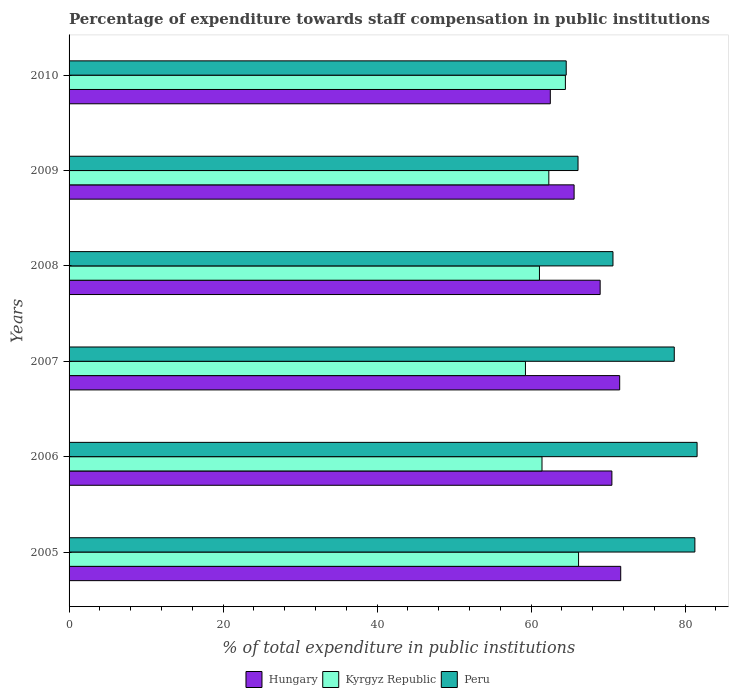How many different coloured bars are there?
Keep it short and to the point. 3. How many groups of bars are there?
Keep it short and to the point. 6. Are the number of bars on each tick of the Y-axis equal?
Make the answer very short. Yes. What is the label of the 3rd group of bars from the top?
Your response must be concise. 2008. In how many cases, is the number of bars for a given year not equal to the number of legend labels?
Provide a short and direct response. 0. What is the percentage of expenditure towards staff compensation in Peru in 2010?
Your answer should be very brief. 64.57. Across all years, what is the maximum percentage of expenditure towards staff compensation in Hungary?
Your answer should be compact. 71.64. Across all years, what is the minimum percentage of expenditure towards staff compensation in Hungary?
Offer a terse response. 62.5. In which year was the percentage of expenditure towards staff compensation in Peru maximum?
Offer a terse response. 2006. What is the total percentage of expenditure towards staff compensation in Hungary in the graph?
Make the answer very short. 410.7. What is the difference between the percentage of expenditure towards staff compensation in Kyrgyz Republic in 2006 and that in 2009?
Give a very brief answer. -0.89. What is the difference between the percentage of expenditure towards staff compensation in Kyrgyz Republic in 2005 and the percentage of expenditure towards staff compensation in Peru in 2008?
Your answer should be compact. -4.47. What is the average percentage of expenditure towards staff compensation in Kyrgyz Republic per year?
Offer a very short reply. 62.45. In the year 2010, what is the difference between the percentage of expenditure towards staff compensation in Kyrgyz Republic and percentage of expenditure towards staff compensation in Hungary?
Offer a very short reply. 1.96. What is the ratio of the percentage of expenditure towards staff compensation in Hungary in 2008 to that in 2010?
Ensure brevity in your answer.  1.1. Is the percentage of expenditure towards staff compensation in Kyrgyz Republic in 2008 less than that in 2009?
Provide a succinct answer. Yes. Is the difference between the percentage of expenditure towards staff compensation in Kyrgyz Republic in 2007 and 2010 greater than the difference between the percentage of expenditure towards staff compensation in Hungary in 2007 and 2010?
Your response must be concise. No. What is the difference between the highest and the second highest percentage of expenditure towards staff compensation in Hungary?
Offer a terse response. 0.13. What is the difference between the highest and the lowest percentage of expenditure towards staff compensation in Hungary?
Offer a terse response. 9.14. In how many years, is the percentage of expenditure towards staff compensation in Hungary greater than the average percentage of expenditure towards staff compensation in Hungary taken over all years?
Your response must be concise. 4. Is the sum of the percentage of expenditure towards staff compensation in Kyrgyz Republic in 2005 and 2009 greater than the maximum percentage of expenditure towards staff compensation in Hungary across all years?
Make the answer very short. Yes. What does the 3rd bar from the top in 2007 represents?
Your response must be concise. Hungary. What does the 3rd bar from the bottom in 2009 represents?
Provide a succinct answer. Peru. Is it the case that in every year, the sum of the percentage of expenditure towards staff compensation in Hungary and percentage of expenditure towards staff compensation in Peru is greater than the percentage of expenditure towards staff compensation in Kyrgyz Republic?
Provide a short and direct response. Yes. How many bars are there?
Your answer should be very brief. 18. How many years are there in the graph?
Give a very brief answer. 6. What is the difference between two consecutive major ticks on the X-axis?
Make the answer very short. 20. Are the values on the major ticks of X-axis written in scientific E-notation?
Make the answer very short. No. Does the graph contain any zero values?
Offer a very short reply. No. Where does the legend appear in the graph?
Your response must be concise. Bottom center. How many legend labels are there?
Offer a very short reply. 3. What is the title of the graph?
Provide a short and direct response. Percentage of expenditure towards staff compensation in public institutions. Does "Small states" appear as one of the legend labels in the graph?
Provide a succinct answer. No. What is the label or title of the X-axis?
Give a very brief answer. % of total expenditure in public institutions. What is the label or title of the Y-axis?
Keep it short and to the point. Years. What is the % of total expenditure in public institutions in Hungary in 2005?
Keep it short and to the point. 71.64. What is the % of total expenditure in public institutions in Kyrgyz Republic in 2005?
Make the answer very short. 66.17. What is the % of total expenditure in public institutions of Peru in 2005?
Give a very brief answer. 81.27. What is the % of total expenditure in public institutions of Hungary in 2006?
Offer a terse response. 70.49. What is the % of total expenditure in public institutions in Kyrgyz Republic in 2006?
Offer a terse response. 61.42. What is the % of total expenditure in public institutions of Peru in 2006?
Your response must be concise. 81.56. What is the % of total expenditure in public institutions of Hungary in 2007?
Your answer should be very brief. 71.51. What is the % of total expenditure in public institutions in Kyrgyz Republic in 2007?
Your response must be concise. 59.27. What is the % of total expenditure in public institutions in Peru in 2007?
Your answer should be very brief. 78.6. What is the % of total expenditure in public institutions of Hungary in 2008?
Your answer should be very brief. 68.97. What is the % of total expenditure in public institutions of Kyrgyz Republic in 2008?
Your response must be concise. 61.09. What is the % of total expenditure in public institutions of Peru in 2008?
Provide a succinct answer. 70.64. What is the % of total expenditure in public institutions in Hungary in 2009?
Provide a succinct answer. 65.59. What is the % of total expenditure in public institutions in Kyrgyz Republic in 2009?
Your response must be concise. 62.3. What is the % of total expenditure in public institutions of Peru in 2009?
Provide a succinct answer. 66.1. What is the % of total expenditure in public institutions of Hungary in 2010?
Give a very brief answer. 62.5. What is the % of total expenditure in public institutions in Kyrgyz Republic in 2010?
Provide a succinct answer. 64.46. What is the % of total expenditure in public institutions of Peru in 2010?
Provide a succinct answer. 64.57. Across all years, what is the maximum % of total expenditure in public institutions in Hungary?
Give a very brief answer. 71.64. Across all years, what is the maximum % of total expenditure in public institutions in Kyrgyz Republic?
Make the answer very short. 66.17. Across all years, what is the maximum % of total expenditure in public institutions of Peru?
Offer a terse response. 81.56. Across all years, what is the minimum % of total expenditure in public institutions in Hungary?
Keep it short and to the point. 62.5. Across all years, what is the minimum % of total expenditure in public institutions of Kyrgyz Republic?
Ensure brevity in your answer.  59.27. Across all years, what is the minimum % of total expenditure in public institutions in Peru?
Make the answer very short. 64.57. What is the total % of total expenditure in public institutions in Hungary in the graph?
Offer a terse response. 410.7. What is the total % of total expenditure in public institutions of Kyrgyz Republic in the graph?
Keep it short and to the point. 374.7. What is the total % of total expenditure in public institutions in Peru in the graph?
Your response must be concise. 442.73. What is the difference between the % of total expenditure in public institutions of Hungary in 2005 and that in 2006?
Your response must be concise. 1.15. What is the difference between the % of total expenditure in public institutions of Kyrgyz Republic in 2005 and that in 2006?
Make the answer very short. 4.75. What is the difference between the % of total expenditure in public institutions of Peru in 2005 and that in 2006?
Make the answer very short. -0.29. What is the difference between the % of total expenditure in public institutions in Hungary in 2005 and that in 2007?
Give a very brief answer. 0.13. What is the difference between the % of total expenditure in public institutions of Kyrgyz Republic in 2005 and that in 2007?
Ensure brevity in your answer.  6.9. What is the difference between the % of total expenditure in public institutions in Peru in 2005 and that in 2007?
Offer a very short reply. 2.68. What is the difference between the % of total expenditure in public institutions of Hungary in 2005 and that in 2008?
Offer a terse response. 2.67. What is the difference between the % of total expenditure in public institutions of Kyrgyz Republic in 2005 and that in 2008?
Your answer should be compact. 5.08. What is the difference between the % of total expenditure in public institutions in Peru in 2005 and that in 2008?
Offer a very short reply. 10.64. What is the difference between the % of total expenditure in public institutions of Hungary in 2005 and that in 2009?
Offer a terse response. 6.05. What is the difference between the % of total expenditure in public institutions of Kyrgyz Republic in 2005 and that in 2009?
Give a very brief answer. 3.86. What is the difference between the % of total expenditure in public institutions of Peru in 2005 and that in 2009?
Provide a short and direct response. 15.17. What is the difference between the % of total expenditure in public institutions in Hungary in 2005 and that in 2010?
Your answer should be compact. 9.14. What is the difference between the % of total expenditure in public institutions in Kyrgyz Republic in 2005 and that in 2010?
Keep it short and to the point. 1.71. What is the difference between the % of total expenditure in public institutions of Peru in 2005 and that in 2010?
Offer a terse response. 16.71. What is the difference between the % of total expenditure in public institutions in Hungary in 2006 and that in 2007?
Your answer should be very brief. -1.01. What is the difference between the % of total expenditure in public institutions of Kyrgyz Republic in 2006 and that in 2007?
Ensure brevity in your answer.  2.15. What is the difference between the % of total expenditure in public institutions in Peru in 2006 and that in 2007?
Make the answer very short. 2.97. What is the difference between the % of total expenditure in public institutions of Hungary in 2006 and that in 2008?
Your answer should be very brief. 1.52. What is the difference between the % of total expenditure in public institutions of Kyrgyz Republic in 2006 and that in 2008?
Your answer should be compact. 0.33. What is the difference between the % of total expenditure in public institutions of Peru in 2006 and that in 2008?
Your answer should be compact. 10.92. What is the difference between the % of total expenditure in public institutions in Hungary in 2006 and that in 2009?
Your answer should be compact. 4.91. What is the difference between the % of total expenditure in public institutions in Kyrgyz Republic in 2006 and that in 2009?
Make the answer very short. -0.89. What is the difference between the % of total expenditure in public institutions in Peru in 2006 and that in 2009?
Your response must be concise. 15.46. What is the difference between the % of total expenditure in public institutions in Hungary in 2006 and that in 2010?
Your answer should be very brief. 8. What is the difference between the % of total expenditure in public institutions of Kyrgyz Republic in 2006 and that in 2010?
Offer a terse response. -3.04. What is the difference between the % of total expenditure in public institutions of Peru in 2006 and that in 2010?
Provide a succinct answer. 17. What is the difference between the % of total expenditure in public institutions of Hungary in 2007 and that in 2008?
Provide a short and direct response. 2.54. What is the difference between the % of total expenditure in public institutions in Kyrgyz Republic in 2007 and that in 2008?
Ensure brevity in your answer.  -1.82. What is the difference between the % of total expenditure in public institutions of Peru in 2007 and that in 2008?
Ensure brevity in your answer.  7.96. What is the difference between the % of total expenditure in public institutions in Hungary in 2007 and that in 2009?
Your answer should be compact. 5.92. What is the difference between the % of total expenditure in public institutions in Kyrgyz Republic in 2007 and that in 2009?
Offer a terse response. -3.04. What is the difference between the % of total expenditure in public institutions of Peru in 2007 and that in 2009?
Give a very brief answer. 12.5. What is the difference between the % of total expenditure in public institutions in Hungary in 2007 and that in 2010?
Make the answer very short. 9.01. What is the difference between the % of total expenditure in public institutions in Kyrgyz Republic in 2007 and that in 2010?
Your answer should be compact. -5.19. What is the difference between the % of total expenditure in public institutions in Peru in 2007 and that in 2010?
Your answer should be very brief. 14.03. What is the difference between the % of total expenditure in public institutions in Hungary in 2008 and that in 2009?
Offer a very short reply. 3.38. What is the difference between the % of total expenditure in public institutions in Kyrgyz Republic in 2008 and that in 2009?
Provide a short and direct response. -1.22. What is the difference between the % of total expenditure in public institutions of Peru in 2008 and that in 2009?
Provide a short and direct response. 4.54. What is the difference between the % of total expenditure in public institutions of Hungary in 2008 and that in 2010?
Offer a very short reply. 6.47. What is the difference between the % of total expenditure in public institutions of Kyrgyz Republic in 2008 and that in 2010?
Your answer should be very brief. -3.37. What is the difference between the % of total expenditure in public institutions of Peru in 2008 and that in 2010?
Your answer should be compact. 6.07. What is the difference between the % of total expenditure in public institutions of Hungary in 2009 and that in 2010?
Provide a short and direct response. 3.09. What is the difference between the % of total expenditure in public institutions of Kyrgyz Republic in 2009 and that in 2010?
Keep it short and to the point. -2.15. What is the difference between the % of total expenditure in public institutions of Peru in 2009 and that in 2010?
Your response must be concise. 1.53. What is the difference between the % of total expenditure in public institutions of Hungary in 2005 and the % of total expenditure in public institutions of Kyrgyz Republic in 2006?
Provide a short and direct response. 10.22. What is the difference between the % of total expenditure in public institutions of Hungary in 2005 and the % of total expenditure in public institutions of Peru in 2006?
Give a very brief answer. -9.92. What is the difference between the % of total expenditure in public institutions of Kyrgyz Republic in 2005 and the % of total expenditure in public institutions of Peru in 2006?
Your response must be concise. -15.39. What is the difference between the % of total expenditure in public institutions of Hungary in 2005 and the % of total expenditure in public institutions of Kyrgyz Republic in 2007?
Ensure brevity in your answer.  12.37. What is the difference between the % of total expenditure in public institutions of Hungary in 2005 and the % of total expenditure in public institutions of Peru in 2007?
Your response must be concise. -6.95. What is the difference between the % of total expenditure in public institutions of Kyrgyz Republic in 2005 and the % of total expenditure in public institutions of Peru in 2007?
Keep it short and to the point. -12.43. What is the difference between the % of total expenditure in public institutions of Hungary in 2005 and the % of total expenditure in public institutions of Kyrgyz Republic in 2008?
Ensure brevity in your answer.  10.56. What is the difference between the % of total expenditure in public institutions of Hungary in 2005 and the % of total expenditure in public institutions of Peru in 2008?
Give a very brief answer. 1.01. What is the difference between the % of total expenditure in public institutions of Kyrgyz Republic in 2005 and the % of total expenditure in public institutions of Peru in 2008?
Offer a very short reply. -4.47. What is the difference between the % of total expenditure in public institutions in Hungary in 2005 and the % of total expenditure in public institutions in Kyrgyz Republic in 2009?
Your answer should be compact. 9.34. What is the difference between the % of total expenditure in public institutions in Hungary in 2005 and the % of total expenditure in public institutions in Peru in 2009?
Offer a very short reply. 5.54. What is the difference between the % of total expenditure in public institutions of Kyrgyz Republic in 2005 and the % of total expenditure in public institutions of Peru in 2009?
Your answer should be compact. 0.07. What is the difference between the % of total expenditure in public institutions of Hungary in 2005 and the % of total expenditure in public institutions of Kyrgyz Republic in 2010?
Your answer should be compact. 7.19. What is the difference between the % of total expenditure in public institutions in Hungary in 2005 and the % of total expenditure in public institutions in Peru in 2010?
Your response must be concise. 7.08. What is the difference between the % of total expenditure in public institutions in Kyrgyz Republic in 2005 and the % of total expenditure in public institutions in Peru in 2010?
Ensure brevity in your answer.  1.6. What is the difference between the % of total expenditure in public institutions of Hungary in 2006 and the % of total expenditure in public institutions of Kyrgyz Republic in 2007?
Your response must be concise. 11.22. What is the difference between the % of total expenditure in public institutions of Hungary in 2006 and the % of total expenditure in public institutions of Peru in 2007?
Provide a succinct answer. -8.1. What is the difference between the % of total expenditure in public institutions in Kyrgyz Republic in 2006 and the % of total expenditure in public institutions in Peru in 2007?
Ensure brevity in your answer.  -17.18. What is the difference between the % of total expenditure in public institutions of Hungary in 2006 and the % of total expenditure in public institutions of Kyrgyz Republic in 2008?
Offer a very short reply. 9.41. What is the difference between the % of total expenditure in public institutions of Hungary in 2006 and the % of total expenditure in public institutions of Peru in 2008?
Keep it short and to the point. -0.14. What is the difference between the % of total expenditure in public institutions in Kyrgyz Republic in 2006 and the % of total expenditure in public institutions in Peru in 2008?
Give a very brief answer. -9.22. What is the difference between the % of total expenditure in public institutions of Hungary in 2006 and the % of total expenditure in public institutions of Kyrgyz Republic in 2009?
Your answer should be compact. 8.19. What is the difference between the % of total expenditure in public institutions of Hungary in 2006 and the % of total expenditure in public institutions of Peru in 2009?
Your answer should be compact. 4.4. What is the difference between the % of total expenditure in public institutions of Kyrgyz Republic in 2006 and the % of total expenditure in public institutions of Peru in 2009?
Offer a very short reply. -4.68. What is the difference between the % of total expenditure in public institutions of Hungary in 2006 and the % of total expenditure in public institutions of Kyrgyz Republic in 2010?
Your response must be concise. 6.04. What is the difference between the % of total expenditure in public institutions in Hungary in 2006 and the % of total expenditure in public institutions in Peru in 2010?
Your answer should be very brief. 5.93. What is the difference between the % of total expenditure in public institutions of Kyrgyz Republic in 2006 and the % of total expenditure in public institutions of Peru in 2010?
Give a very brief answer. -3.15. What is the difference between the % of total expenditure in public institutions in Hungary in 2007 and the % of total expenditure in public institutions in Kyrgyz Republic in 2008?
Your response must be concise. 10.42. What is the difference between the % of total expenditure in public institutions in Hungary in 2007 and the % of total expenditure in public institutions in Peru in 2008?
Your response must be concise. 0.87. What is the difference between the % of total expenditure in public institutions of Kyrgyz Republic in 2007 and the % of total expenditure in public institutions of Peru in 2008?
Make the answer very short. -11.37. What is the difference between the % of total expenditure in public institutions in Hungary in 2007 and the % of total expenditure in public institutions in Kyrgyz Republic in 2009?
Provide a short and direct response. 9.2. What is the difference between the % of total expenditure in public institutions of Hungary in 2007 and the % of total expenditure in public institutions of Peru in 2009?
Your response must be concise. 5.41. What is the difference between the % of total expenditure in public institutions in Kyrgyz Republic in 2007 and the % of total expenditure in public institutions in Peru in 2009?
Ensure brevity in your answer.  -6.83. What is the difference between the % of total expenditure in public institutions of Hungary in 2007 and the % of total expenditure in public institutions of Kyrgyz Republic in 2010?
Offer a very short reply. 7.05. What is the difference between the % of total expenditure in public institutions of Hungary in 2007 and the % of total expenditure in public institutions of Peru in 2010?
Your answer should be compact. 6.94. What is the difference between the % of total expenditure in public institutions of Kyrgyz Republic in 2007 and the % of total expenditure in public institutions of Peru in 2010?
Make the answer very short. -5.3. What is the difference between the % of total expenditure in public institutions in Hungary in 2008 and the % of total expenditure in public institutions in Kyrgyz Republic in 2009?
Provide a short and direct response. 6.67. What is the difference between the % of total expenditure in public institutions of Hungary in 2008 and the % of total expenditure in public institutions of Peru in 2009?
Offer a terse response. 2.87. What is the difference between the % of total expenditure in public institutions of Kyrgyz Republic in 2008 and the % of total expenditure in public institutions of Peru in 2009?
Your answer should be very brief. -5.01. What is the difference between the % of total expenditure in public institutions of Hungary in 2008 and the % of total expenditure in public institutions of Kyrgyz Republic in 2010?
Your answer should be compact. 4.51. What is the difference between the % of total expenditure in public institutions in Hungary in 2008 and the % of total expenditure in public institutions in Peru in 2010?
Provide a succinct answer. 4.41. What is the difference between the % of total expenditure in public institutions in Kyrgyz Republic in 2008 and the % of total expenditure in public institutions in Peru in 2010?
Your answer should be very brief. -3.48. What is the difference between the % of total expenditure in public institutions in Hungary in 2009 and the % of total expenditure in public institutions in Kyrgyz Republic in 2010?
Keep it short and to the point. 1.13. What is the difference between the % of total expenditure in public institutions in Hungary in 2009 and the % of total expenditure in public institutions in Peru in 2010?
Ensure brevity in your answer.  1.02. What is the difference between the % of total expenditure in public institutions of Kyrgyz Republic in 2009 and the % of total expenditure in public institutions of Peru in 2010?
Your response must be concise. -2.26. What is the average % of total expenditure in public institutions in Hungary per year?
Your response must be concise. 68.45. What is the average % of total expenditure in public institutions of Kyrgyz Republic per year?
Your answer should be compact. 62.45. What is the average % of total expenditure in public institutions in Peru per year?
Give a very brief answer. 73.79. In the year 2005, what is the difference between the % of total expenditure in public institutions of Hungary and % of total expenditure in public institutions of Kyrgyz Republic?
Your answer should be compact. 5.47. In the year 2005, what is the difference between the % of total expenditure in public institutions of Hungary and % of total expenditure in public institutions of Peru?
Provide a succinct answer. -9.63. In the year 2005, what is the difference between the % of total expenditure in public institutions in Kyrgyz Republic and % of total expenditure in public institutions in Peru?
Your response must be concise. -15.1. In the year 2006, what is the difference between the % of total expenditure in public institutions of Hungary and % of total expenditure in public institutions of Kyrgyz Republic?
Give a very brief answer. 9.08. In the year 2006, what is the difference between the % of total expenditure in public institutions of Hungary and % of total expenditure in public institutions of Peru?
Your answer should be compact. -11.07. In the year 2006, what is the difference between the % of total expenditure in public institutions in Kyrgyz Republic and % of total expenditure in public institutions in Peru?
Provide a succinct answer. -20.14. In the year 2007, what is the difference between the % of total expenditure in public institutions of Hungary and % of total expenditure in public institutions of Kyrgyz Republic?
Provide a succinct answer. 12.24. In the year 2007, what is the difference between the % of total expenditure in public institutions in Hungary and % of total expenditure in public institutions in Peru?
Give a very brief answer. -7.09. In the year 2007, what is the difference between the % of total expenditure in public institutions in Kyrgyz Republic and % of total expenditure in public institutions in Peru?
Keep it short and to the point. -19.33. In the year 2008, what is the difference between the % of total expenditure in public institutions in Hungary and % of total expenditure in public institutions in Kyrgyz Republic?
Provide a succinct answer. 7.88. In the year 2008, what is the difference between the % of total expenditure in public institutions in Hungary and % of total expenditure in public institutions in Peru?
Your response must be concise. -1.67. In the year 2008, what is the difference between the % of total expenditure in public institutions of Kyrgyz Republic and % of total expenditure in public institutions of Peru?
Ensure brevity in your answer.  -9.55. In the year 2009, what is the difference between the % of total expenditure in public institutions of Hungary and % of total expenditure in public institutions of Kyrgyz Republic?
Ensure brevity in your answer.  3.28. In the year 2009, what is the difference between the % of total expenditure in public institutions in Hungary and % of total expenditure in public institutions in Peru?
Make the answer very short. -0.51. In the year 2009, what is the difference between the % of total expenditure in public institutions in Kyrgyz Republic and % of total expenditure in public institutions in Peru?
Provide a succinct answer. -3.79. In the year 2010, what is the difference between the % of total expenditure in public institutions of Hungary and % of total expenditure in public institutions of Kyrgyz Republic?
Your response must be concise. -1.96. In the year 2010, what is the difference between the % of total expenditure in public institutions in Hungary and % of total expenditure in public institutions in Peru?
Your answer should be very brief. -2.07. In the year 2010, what is the difference between the % of total expenditure in public institutions in Kyrgyz Republic and % of total expenditure in public institutions in Peru?
Provide a short and direct response. -0.11. What is the ratio of the % of total expenditure in public institutions of Hungary in 2005 to that in 2006?
Keep it short and to the point. 1.02. What is the ratio of the % of total expenditure in public institutions in Kyrgyz Republic in 2005 to that in 2006?
Your answer should be compact. 1.08. What is the ratio of the % of total expenditure in public institutions in Kyrgyz Republic in 2005 to that in 2007?
Provide a short and direct response. 1.12. What is the ratio of the % of total expenditure in public institutions of Peru in 2005 to that in 2007?
Your response must be concise. 1.03. What is the ratio of the % of total expenditure in public institutions in Hungary in 2005 to that in 2008?
Keep it short and to the point. 1.04. What is the ratio of the % of total expenditure in public institutions of Kyrgyz Republic in 2005 to that in 2008?
Offer a terse response. 1.08. What is the ratio of the % of total expenditure in public institutions in Peru in 2005 to that in 2008?
Provide a succinct answer. 1.15. What is the ratio of the % of total expenditure in public institutions in Hungary in 2005 to that in 2009?
Your response must be concise. 1.09. What is the ratio of the % of total expenditure in public institutions in Kyrgyz Republic in 2005 to that in 2009?
Offer a terse response. 1.06. What is the ratio of the % of total expenditure in public institutions of Peru in 2005 to that in 2009?
Your answer should be very brief. 1.23. What is the ratio of the % of total expenditure in public institutions of Hungary in 2005 to that in 2010?
Ensure brevity in your answer.  1.15. What is the ratio of the % of total expenditure in public institutions of Kyrgyz Republic in 2005 to that in 2010?
Offer a very short reply. 1.03. What is the ratio of the % of total expenditure in public institutions in Peru in 2005 to that in 2010?
Give a very brief answer. 1.26. What is the ratio of the % of total expenditure in public institutions in Hungary in 2006 to that in 2007?
Your answer should be compact. 0.99. What is the ratio of the % of total expenditure in public institutions in Kyrgyz Republic in 2006 to that in 2007?
Give a very brief answer. 1.04. What is the ratio of the % of total expenditure in public institutions of Peru in 2006 to that in 2007?
Provide a short and direct response. 1.04. What is the ratio of the % of total expenditure in public institutions of Hungary in 2006 to that in 2008?
Give a very brief answer. 1.02. What is the ratio of the % of total expenditure in public institutions in Kyrgyz Republic in 2006 to that in 2008?
Your answer should be very brief. 1.01. What is the ratio of the % of total expenditure in public institutions in Peru in 2006 to that in 2008?
Ensure brevity in your answer.  1.15. What is the ratio of the % of total expenditure in public institutions of Hungary in 2006 to that in 2009?
Give a very brief answer. 1.07. What is the ratio of the % of total expenditure in public institutions in Kyrgyz Republic in 2006 to that in 2009?
Offer a very short reply. 0.99. What is the ratio of the % of total expenditure in public institutions of Peru in 2006 to that in 2009?
Keep it short and to the point. 1.23. What is the ratio of the % of total expenditure in public institutions of Hungary in 2006 to that in 2010?
Offer a terse response. 1.13. What is the ratio of the % of total expenditure in public institutions in Kyrgyz Republic in 2006 to that in 2010?
Provide a succinct answer. 0.95. What is the ratio of the % of total expenditure in public institutions in Peru in 2006 to that in 2010?
Your answer should be compact. 1.26. What is the ratio of the % of total expenditure in public institutions in Hungary in 2007 to that in 2008?
Make the answer very short. 1.04. What is the ratio of the % of total expenditure in public institutions in Kyrgyz Republic in 2007 to that in 2008?
Provide a short and direct response. 0.97. What is the ratio of the % of total expenditure in public institutions in Peru in 2007 to that in 2008?
Offer a terse response. 1.11. What is the ratio of the % of total expenditure in public institutions in Hungary in 2007 to that in 2009?
Ensure brevity in your answer.  1.09. What is the ratio of the % of total expenditure in public institutions of Kyrgyz Republic in 2007 to that in 2009?
Offer a very short reply. 0.95. What is the ratio of the % of total expenditure in public institutions in Peru in 2007 to that in 2009?
Offer a very short reply. 1.19. What is the ratio of the % of total expenditure in public institutions of Hungary in 2007 to that in 2010?
Offer a very short reply. 1.14. What is the ratio of the % of total expenditure in public institutions of Kyrgyz Republic in 2007 to that in 2010?
Your response must be concise. 0.92. What is the ratio of the % of total expenditure in public institutions of Peru in 2007 to that in 2010?
Make the answer very short. 1.22. What is the ratio of the % of total expenditure in public institutions of Hungary in 2008 to that in 2009?
Offer a very short reply. 1.05. What is the ratio of the % of total expenditure in public institutions of Kyrgyz Republic in 2008 to that in 2009?
Offer a terse response. 0.98. What is the ratio of the % of total expenditure in public institutions in Peru in 2008 to that in 2009?
Provide a short and direct response. 1.07. What is the ratio of the % of total expenditure in public institutions of Hungary in 2008 to that in 2010?
Offer a terse response. 1.1. What is the ratio of the % of total expenditure in public institutions in Kyrgyz Republic in 2008 to that in 2010?
Keep it short and to the point. 0.95. What is the ratio of the % of total expenditure in public institutions in Peru in 2008 to that in 2010?
Your answer should be compact. 1.09. What is the ratio of the % of total expenditure in public institutions of Hungary in 2009 to that in 2010?
Ensure brevity in your answer.  1.05. What is the ratio of the % of total expenditure in public institutions of Kyrgyz Republic in 2009 to that in 2010?
Give a very brief answer. 0.97. What is the ratio of the % of total expenditure in public institutions in Peru in 2009 to that in 2010?
Offer a terse response. 1.02. What is the difference between the highest and the second highest % of total expenditure in public institutions in Hungary?
Offer a very short reply. 0.13. What is the difference between the highest and the second highest % of total expenditure in public institutions of Kyrgyz Republic?
Offer a very short reply. 1.71. What is the difference between the highest and the second highest % of total expenditure in public institutions of Peru?
Keep it short and to the point. 0.29. What is the difference between the highest and the lowest % of total expenditure in public institutions of Hungary?
Provide a succinct answer. 9.14. What is the difference between the highest and the lowest % of total expenditure in public institutions in Kyrgyz Republic?
Provide a short and direct response. 6.9. What is the difference between the highest and the lowest % of total expenditure in public institutions in Peru?
Your answer should be compact. 17. 